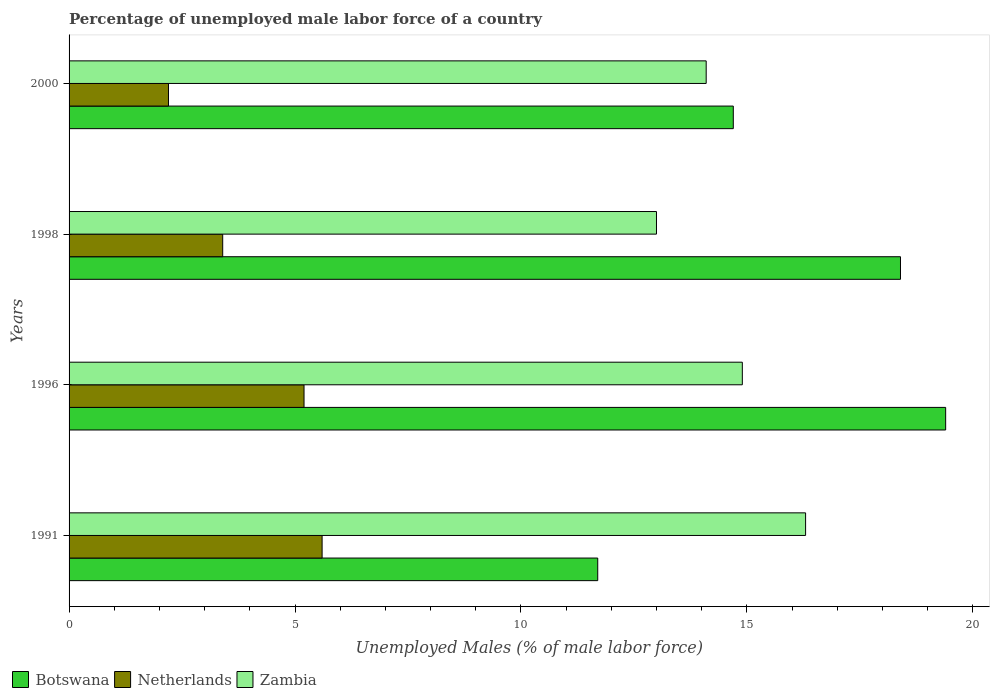How many different coloured bars are there?
Your answer should be very brief. 3. How many groups of bars are there?
Provide a short and direct response. 4. What is the percentage of unemployed male labor force in Netherlands in 1996?
Give a very brief answer. 5.2. Across all years, what is the maximum percentage of unemployed male labor force in Botswana?
Your response must be concise. 19.4. Across all years, what is the minimum percentage of unemployed male labor force in Botswana?
Ensure brevity in your answer.  11.7. In which year was the percentage of unemployed male labor force in Netherlands minimum?
Your answer should be very brief. 2000. What is the total percentage of unemployed male labor force in Botswana in the graph?
Your answer should be compact. 64.2. What is the difference between the percentage of unemployed male labor force in Zambia in 1998 and that in 2000?
Provide a short and direct response. -1.1. What is the difference between the percentage of unemployed male labor force in Zambia in 1991 and the percentage of unemployed male labor force in Netherlands in 1998?
Make the answer very short. 12.9. What is the average percentage of unemployed male labor force in Zambia per year?
Provide a short and direct response. 14.57. In the year 1991, what is the difference between the percentage of unemployed male labor force in Netherlands and percentage of unemployed male labor force in Zambia?
Make the answer very short. -10.7. In how many years, is the percentage of unemployed male labor force in Netherlands greater than 13 %?
Your response must be concise. 0. What is the ratio of the percentage of unemployed male labor force in Netherlands in 1996 to that in 1998?
Give a very brief answer. 1.53. What is the difference between the highest and the second highest percentage of unemployed male labor force in Zambia?
Provide a short and direct response. 1.4. What is the difference between the highest and the lowest percentage of unemployed male labor force in Netherlands?
Keep it short and to the point. 3.4. Is the sum of the percentage of unemployed male labor force in Zambia in 1991 and 2000 greater than the maximum percentage of unemployed male labor force in Botswana across all years?
Your response must be concise. Yes. What does the 1st bar from the top in 2000 represents?
Give a very brief answer. Zambia. What does the 3rd bar from the bottom in 2000 represents?
Offer a very short reply. Zambia. Is it the case that in every year, the sum of the percentage of unemployed male labor force in Netherlands and percentage of unemployed male labor force in Botswana is greater than the percentage of unemployed male labor force in Zambia?
Offer a terse response. Yes. How many years are there in the graph?
Offer a terse response. 4. What is the difference between two consecutive major ticks on the X-axis?
Offer a very short reply. 5. Does the graph contain any zero values?
Keep it short and to the point. No. Does the graph contain grids?
Your response must be concise. No. Where does the legend appear in the graph?
Your answer should be very brief. Bottom left. How many legend labels are there?
Make the answer very short. 3. What is the title of the graph?
Keep it short and to the point. Percentage of unemployed male labor force of a country. Does "Burkina Faso" appear as one of the legend labels in the graph?
Ensure brevity in your answer.  No. What is the label or title of the X-axis?
Your answer should be very brief. Unemployed Males (% of male labor force). What is the label or title of the Y-axis?
Keep it short and to the point. Years. What is the Unemployed Males (% of male labor force) in Botswana in 1991?
Make the answer very short. 11.7. What is the Unemployed Males (% of male labor force) in Netherlands in 1991?
Your response must be concise. 5.6. What is the Unemployed Males (% of male labor force) of Zambia in 1991?
Keep it short and to the point. 16.3. What is the Unemployed Males (% of male labor force) of Botswana in 1996?
Provide a short and direct response. 19.4. What is the Unemployed Males (% of male labor force) of Netherlands in 1996?
Offer a very short reply. 5.2. What is the Unemployed Males (% of male labor force) of Zambia in 1996?
Ensure brevity in your answer.  14.9. What is the Unemployed Males (% of male labor force) of Botswana in 1998?
Offer a terse response. 18.4. What is the Unemployed Males (% of male labor force) of Netherlands in 1998?
Your response must be concise. 3.4. What is the Unemployed Males (% of male labor force) of Botswana in 2000?
Offer a terse response. 14.7. What is the Unemployed Males (% of male labor force) of Netherlands in 2000?
Provide a short and direct response. 2.2. What is the Unemployed Males (% of male labor force) in Zambia in 2000?
Give a very brief answer. 14.1. Across all years, what is the maximum Unemployed Males (% of male labor force) of Botswana?
Provide a short and direct response. 19.4. Across all years, what is the maximum Unemployed Males (% of male labor force) in Netherlands?
Offer a terse response. 5.6. Across all years, what is the maximum Unemployed Males (% of male labor force) of Zambia?
Provide a succinct answer. 16.3. Across all years, what is the minimum Unemployed Males (% of male labor force) of Botswana?
Keep it short and to the point. 11.7. Across all years, what is the minimum Unemployed Males (% of male labor force) in Netherlands?
Offer a terse response. 2.2. Across all years, what is the minimum Unemployed Males (% of male labor force) of Zambia?
Ensure brevity in your answer.  13. What is the total Unemployed Males (% of male labor force) in Botswana in the graph?
Provide a short and direct response. 64.2. What is the total Unemployed Males (% of male labor force) of Zambia in the graph?
Provide a succinct answer. 58.3. What is the difference between the Unemployed Males (% of male labor force) in Zambia in 1991 and that in 1996?
Your answer should be compact. 1.4. What is the difference between the Unemployed Males (% of male labor force) in Netherlands in 1991 and that in 1998?
Keep it short and to the point. 2.2. What is the difference between the Unemployed Males (% of male labor force) in Botswana in 1991 and that in 2000?
Provide a short and direct response. -3. What is the difference between the Unemployed Males (% of male labor force) in Zambia in 1991 and that in 2000?
Provide a succinct answer. 2.2. What is the difference between the Unemployed Males (% of male labor force) of Botswana in 1996 and that in 1998?
Give a very brief answer. 1. What is the difference between the Unemployed Males (% of male labor force) in Netherlands in 1996 and that in 1998?
Give a very brief answer. 1.8. What is the difference between the Unemployed Males (% of male labor force) in Botswana in 1996 and that in 2000?
Offer a terse response. 4.7. What is the difference between the Unemployed Males (% of male labor force) in Netherlands in 1996 and that in 2000?
Ensure brevity in your answer.  3. What is the difference between the Unemployed Males (% of male labor force) in Zambia in 1996 and that in 2000?
Make the answer very short. 0.8. What is the difference between the Unemployed Males (% of male labor force) in Botswana in 1998 and that in 2000?
Your answer should be compact. 3.7. What is the difference between the Unemployed Males (% of male labor force) of Zambia in 1998 and that in 2000?
Ensure brevity in your answer.  -1.1. What is the difference between the Unemployed Males (% of male labor force) of Netherlands in 1991 and the Unemployed Males (% of male labor force) of Zambia in 1996?
Provide a short and direct response. -9.3. What is the difference between the Unemployed Males (% of male labor force) of Botswana in 1991 and the Unemployed Males (% of male labor force) of Netherlands in 1998?
Give a very brief answer. 8.3. What is the difference between the Unemployed Males (% of male labor force) of Botswana in 1991 and the Unemployed Males (% of male labor force) of Zambia in 1998?
Make the answer very short. -1.3. What is the difference between the Unemployed Males (% of male labor force) of Botswana in 1996 and the Unemployed Males (% of male labor force) of Netherlands in 1998?
Provide a short and direct response. 16. What is the difference between the Unemployed Males (% of male labor force) of Botswana in 1996 and the Unemployed Males (% of male labor force) of Zambia in 1998?
Give a very brief answer. 6.4. What is the difference between the Unemployed Males (% of male labor force) in Botswana in 1996 and the Unemployed Males (% of male labor force) in Netherlands in 2000?
Your answer should be compact. 17.2. What is the difference between the Unemployed Males (% of male labor force) of Botswana in 1996 and the Unemployed Males (% of male labor force) of Zambia in 2000?
Provide a succinct answer. 5.3. What is the difference between the Unemployed Males (% of male labor force) of Netherlands in 1996 and the Unemployed Males (% of male labor force) of Zambia in 2000?
Offer a terse response. -8.9. What is the difference between the Unemployed Males (% of male labor force) of Botswana in 1998 and the Unemployed Males (% of male labor force) of Netherlands in 2000?
Keep it short and to the point. 16.2. What is the difference between the Unemployed Males (% of male labor force) of Botswana in 1998 and the Unemployed Males (% of male labor force) of Zambia in 2000?
Offer a very short reply. 4.3. What is the average Unemployed Males (% of male labor force) of Botswana per year?
Offer a terse response. 16.05. What is the average Unemployed Males (% of male labor force) in Zambia per year?
Provide a succinct answer. 14.57. In the year 1991, what is the difference between the Unemployed Males (% of male labor force) of Botswana and Unemployed Males (% of male labor force) of Netherlands?
Provide a short and direct response. 6.1. In the year 1991, what is the difference between the Unemployed Males (% of male labor force) of Netherlands and Unemployed Males (% of male labor force) of Zambia?
Give a very brief answer. -10.7. In the year 1996, what is the difference between the Unemployed Males (% of male labor force) in Netherlands and Unemployed Males (% of male labor force) in Zambia?
Ensure brevity in your answer.  -9.7. In the year 1998, what is the difference between the Unemployed Males (% of male labor force) in Botswana and Unemployed Males (% of male labor force) in Zambia?
Offer a very short reply. 5.4. In the year 2000, what is the difference between the Unemployed Males (% of male labor force) in Botswana and Unemployed Males (% of male labor force) in Netherlands?
Your answer should be very brief. 12.5. In the year 2000, what is the difference between the Unemployed Males (% of male labor force) in Botswana and Unemployed Males (% of male labor force) in Zambia?
Ensure brevity in your answer.  0.6. In the year 2000, what is the difference between the Unemployed Males (% of male labor force) in Netherlands and Unemployed Males (% of male labor force) in Zambia?
Provide a succinct answer. -11.9. What is the ratio of the Unemployed Males (% of male labor force) in Botswana in 1991 to that in 1996?
Make the answer very short. 0.6. What is the ratio of the Unemployed Males (% of male labor force) in Zambia in 1991 to that in 1996?
Ensure brevity in your answer.  1.09. What is the ratio of the Unemployed Males (% of male labor force) in Botswana in 1991 to that in 1998?
Offer a very short reply. 0.64. What is the ratio of the Unemployed Males (% of male labor force) of Netherlands in 1991 to that in 1998?
Provide a succinct answer. 1.65. What is the ratio of the Unemployed Males (% of male labor force) of Zambia in 1991 to that in 1998?
Give a very brief answer. 1.25. What is the ratio of the Unemployed Males (% of male labor force) in Botswana in 1991 to that in 2000?
Your answer should be compact. 0.8. What is the ratio of the Unemployed Males (% of male labor force) of Netherlands in 1991 to that in 2000?
Ensure brevity in your answer.  2.55. What is the ratio of the Unemployed Males (% of male labor force) of Zambia in 1991 to that in 2000?
Your answer should be very brief. 1.16. What is the ratio of the Unemployed Males (% of male labor force) of Botswana in 1996 to that in 1998?
Your answer should be very brief. 1.05. What is the ratio of the Unemployed Males (% of male labor force) in Netherlands in 1996 to that in 1998?
Give a very brief answer. 1.53. What is the ratio of the Unemployed Males (% of male labor force) in Zambia in 1996 to that in 1998?
Provide a succinct answer. 1.15. What is the ratio of the Unemployed Males (% of male labor force) in Botswana in 1996 to that in 2000?
Offer a very short reply. 1.32. What is the ratio of the Unemployed Males (% of male labor force) of Netherlands in 1996 to that in 2000?
Provide a succinct answer. 2.36. What is the ratio of the Unemployed Males (% of male labor force) in Zambia in 1996 to that in 2000?
Your response must be concise. 1.06. What is the ratio of the Unemployed Males (% of male labor force) in Botswana in 1998 to that in 2000?
Give a very brief answer. 1.25. What is the ratio of the Unemployed Males (% of male labor force) of Netherlands in 1998 to that in 2000?
Your answer should be very brief. 1.55. What is the ratio of the Unemployed Males (% of male labor force) of Zambia in 1998 to that in 2000?
Your response must be concise. 0.92. What is the difference between the highest and the second highest Unemployed Males (% of male labor force) of Botswana?
Your response must be concise. 1. What is the difference between the highest and the second highest Unemployed Males (% of male labor force) in Netherlands?
Offer a very short reply. 0.4. What is the difference between the highest and the second highest Unemployed Males (% of male labor force) in Zambia?
Your response must be concise. 1.4. What is the difference between the highest and the lowest Unemployed Males (% of male labor force) in Netherlands?
Your answer should be very brief. 3.4. What is the difference between the highest and the lowest Unemployed Males (% of male labor force) of Zambia?
Offer a very short reply. 3.3. 